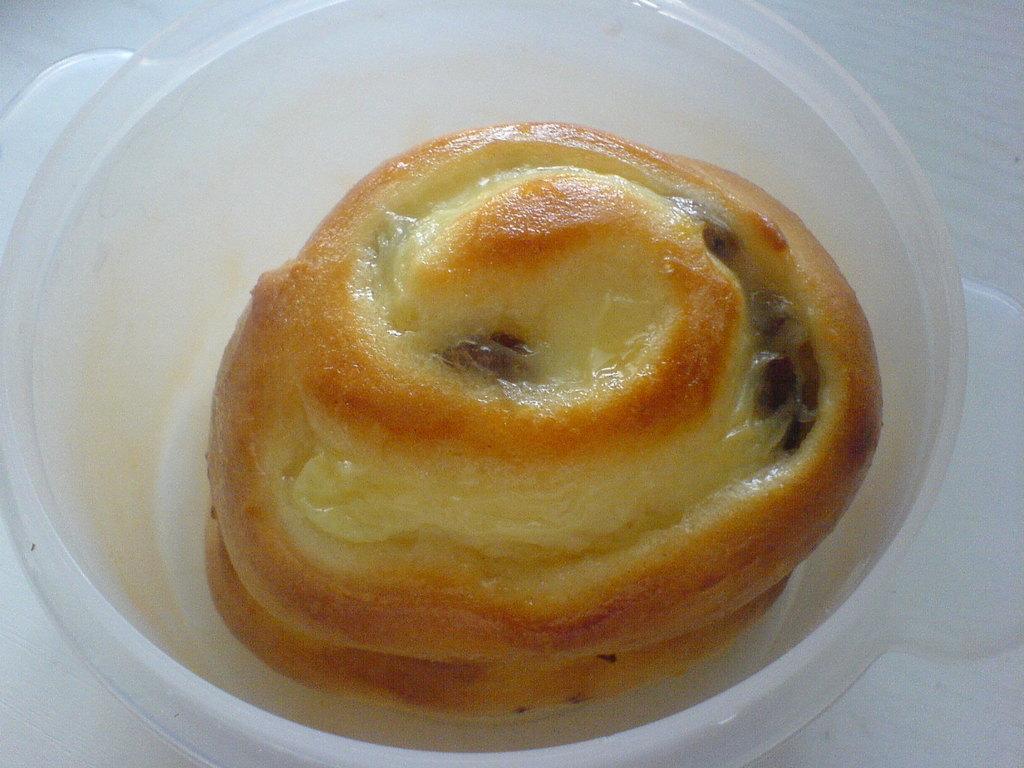Could you give a brief overview of what you see in this image? In this image I can see food which is of brown and cream colour in a plastic bowl. 